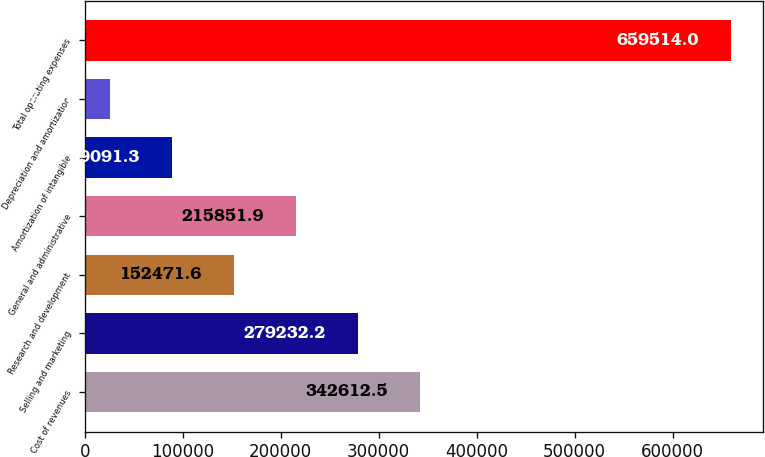Convert chart. <chart><loc_0><loc_0><loc_500><loc_500><bar_chart><fcel>Cost of revenues<fcel>Selling and marketing<fcel>Research and development<fcel>General and administrative<fcel>Amortization of intangible<fcel>Depreciation and amortization<fcel>Total operating expenses<nl><fcel>342612<fcel>279232<fcel>152472<fcel>215852<fcel>89091.3<fcel>25711<fcel>659514<nl></chart> 